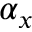Convert formula to latex. <formula><loc_0><loc_0><loc_500><loc_500>\alpha _ { x }</formula> 